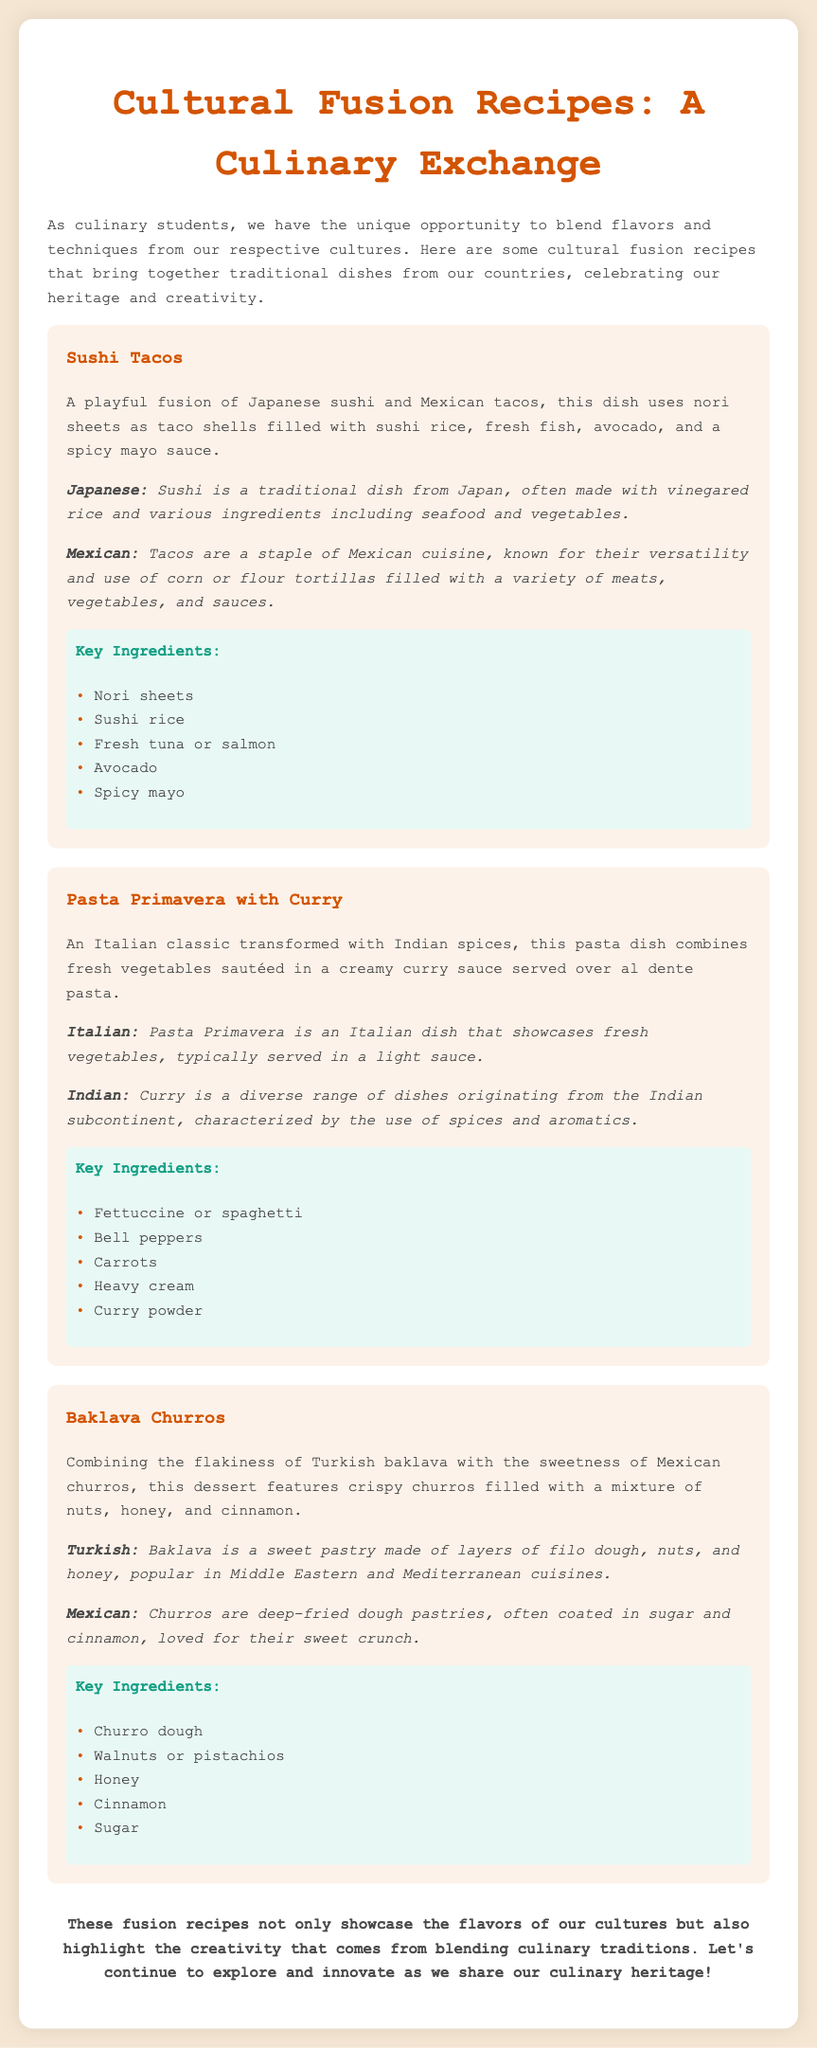What is the title of the document? The title of the document is presented in the header section of the rendered document.
Answer: Cultural Fusion Recipes: A Culinary Exchange How many recipes are featured in the document? The number of recipes is indicated by the number of recipe sections included in the content.
Answer: Three What is the first fusion recipe mentioned? The first recipe is the one listed at the beginning of the recipe sections in the document.
Answer: Sushi Tacos What traditional dish is combined with Indian spices in the second recipe? This dish is mentioned in the description of the second recipe which highlights its Italian origins.
Answer: Pasta Primavera Which country does baklava originate from? The cultural background section for the Baklava Churros recipe specifies the origin of baklava.
Answer: Turkish What main ingredient is used in the Sushi Tacos? The key ingredients are listed for Sushi Tacos and one of them is specifically mentioned first.
Answer: Nori sheets Which fusion dish features crispy churros? This detail is found in the name and description of the fusion dessert in the document.
Answer: Baklava Churros What is the main focus of the document? The overall intention of the document is summarized in the introduction and conclusion sections.
Answer: Cultural fusion recipes What is the last phrase in the conclusion? The final sentence in the conclusion section summarizes the purpose of the recipes presented.
Answer: culinary heritage! 